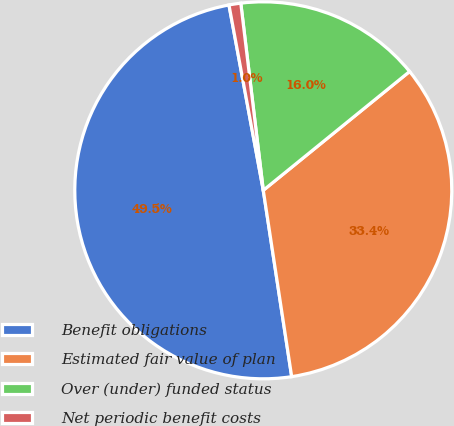<chart> <loc_0><loc_0><loc_500><loc_500><pie_chart><fcel>Benefit obligations<fcel>Estimated fair value of plan<fcel>Over (under) funded status<fcel>Net periodic benefit costs<nl><fcel>49.5%<fcel>33.45%<fcel>16.05%<fcel>1.01%<nl></chart> 